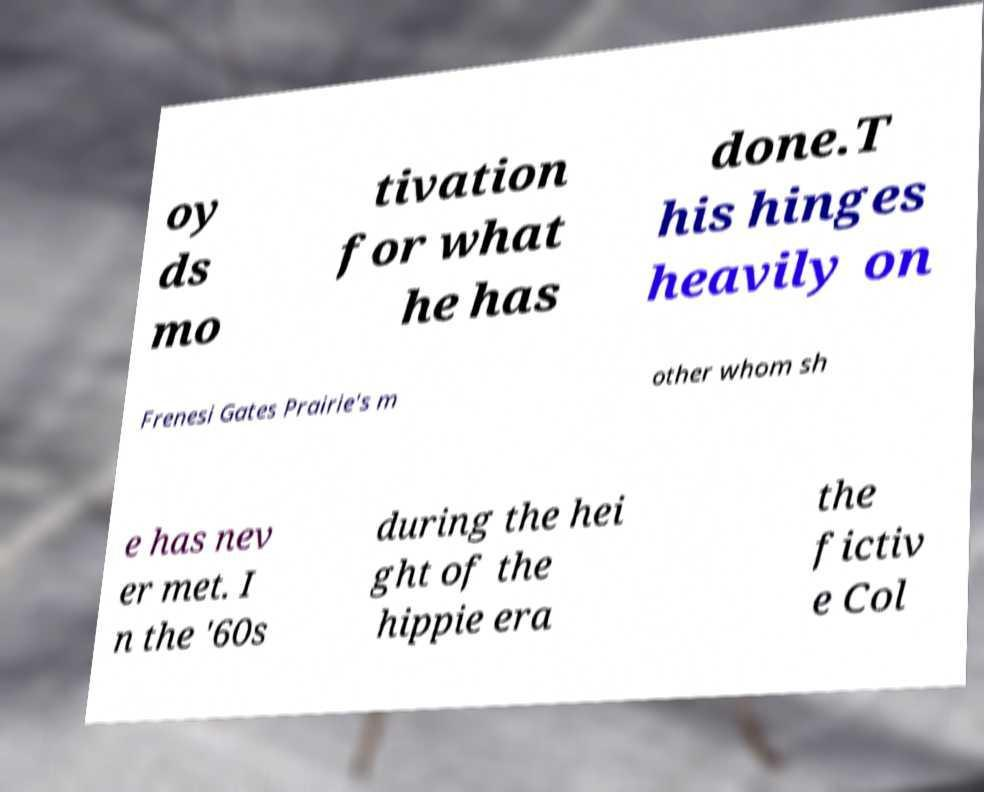What messages or text are displayed in this image? I need them in a readable, typed format. oy ds mo tivation for what he has done.T his hinges heavily on Frenesi Gates Prairie's m other whom sh e has nev er met. I n the '60s during the hei ght of the hippie era the fictiv e Col 